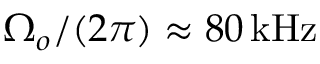Convert formula to latex. <formula><loc_0><loc_0><loc_500><loc_500>\Omega _ { o } / ( 2 \pi ) \approx 8 0 { \, k H z }</formula> 